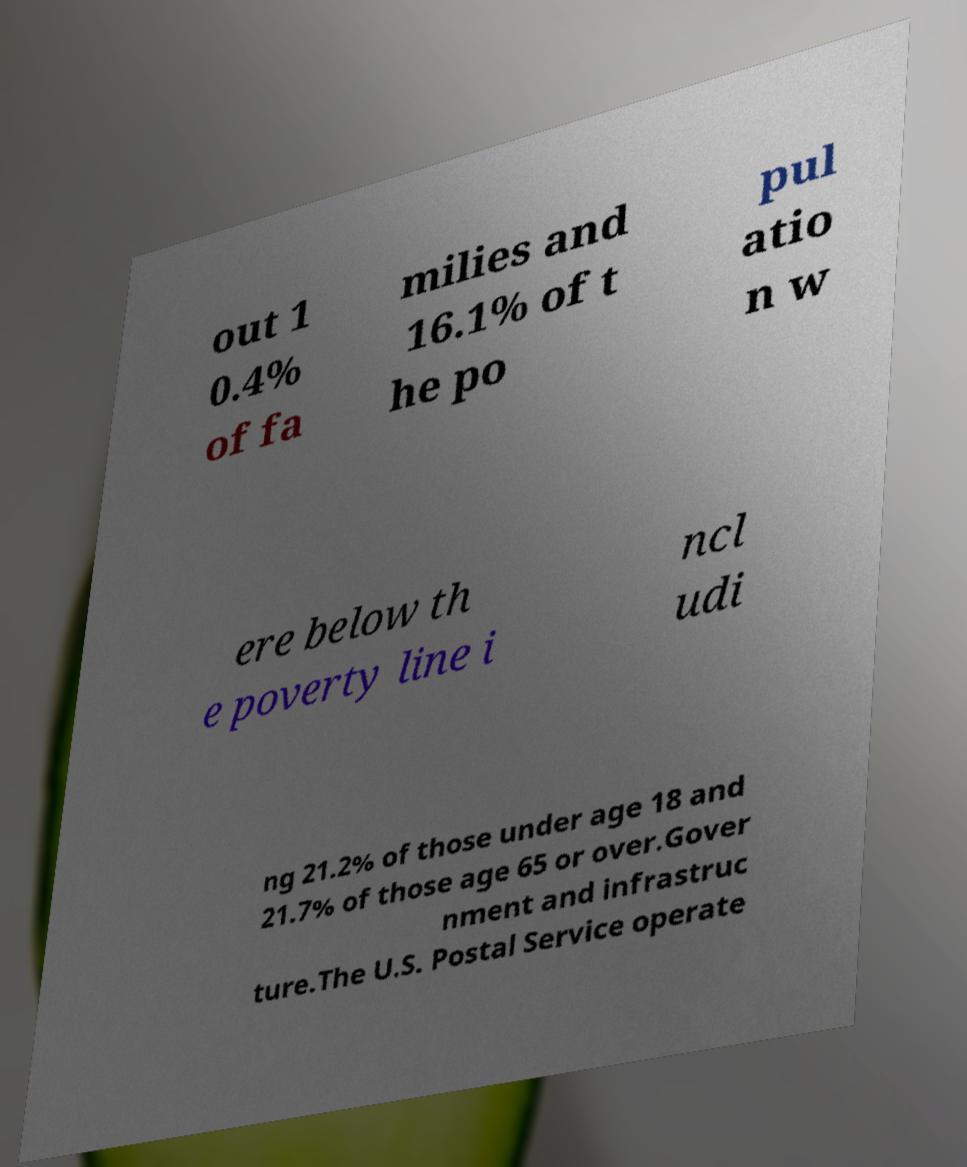Please read and relay the text visible in this image. What does it say? out 1 0.4% of fa milies and 16.1% of t he po pul atio n w ere below th e poverty line i ncl udi ng 21.2% of those under age 18 and 21.7% of those age 65 or over.Gover nment and infrastruc ture.The U.S. Postal Service operate 